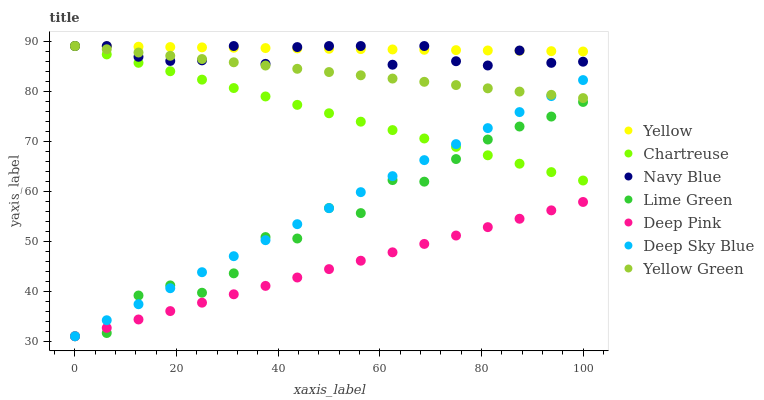Does Deep Pink have the minimum area under the curve?
Answer yes or no. Yes. Does Yellow have the maximum area under the curve?
Answer yes or no. Yes. Does Yellow Green have the minimum area under the curve?
Answer yes or no. No. Does Yellow Green have the maximum area under the curve?
Answer yes or no. No. Is Deep Sky Blue the smoothest?
Answer yes or no. Yes. Is Lime Green the roughest?
Answer yes or no. Yes. Is Yellow Green the smoothest?
Answer yes or no. No. Is Yellow Green the roughest?
Answer yes or no. No. Does Deep Pink have the lowest value?
Answer yes or no. Yes. Does Yellow Green have the lowest value?
Answer yes or no. No. Does Chartreuse have the highest value?
Answer yes or no. Yes. Does Deep Sky Blue have the highest value?
Answer yes or no. No. Is Deep Pink less than Yellow?
Answer yes or no. Yes. Is Yellow greater than Deep Sky Blue?
Answer yes or no. Yes. Does Deep Sky Blue intersect Yellow Green?
Answer yes or no. Yes. Is Deep Sky Blue less than Yellow Green?
Answer yes or no. No. Is Deep Sky Blue greater than Yellow Green?
Answer yes or no. No. Does Deep Pink intersect Yellow?
Answer yes or no. No. 